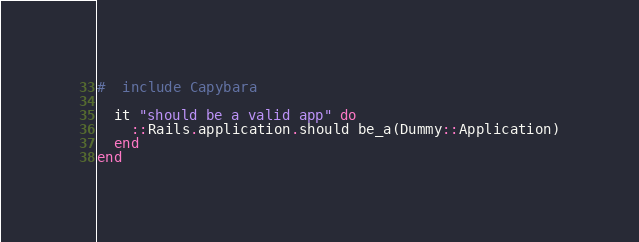<code> <loc_0><loc_0><loc_500><loc_500><_Ruby_>#  include Capybara
  
  it "should be a valid app" do
    ::Rails.application.should be_a(Dummy::Application)
  end
end
</code> 